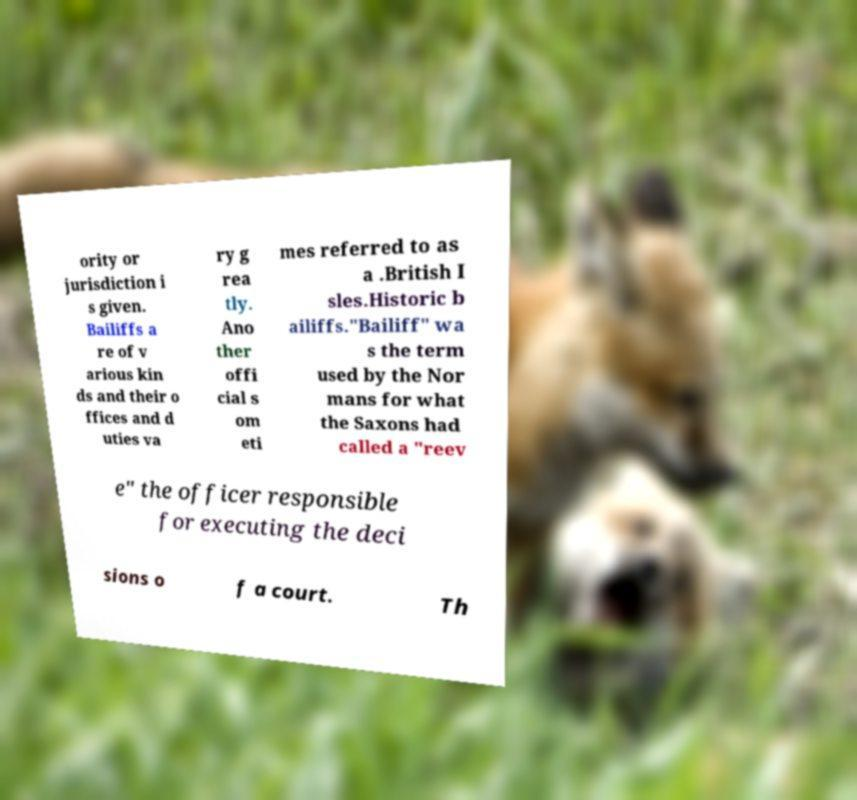Please identify and transcribe the text found in this image. ority or jurisdiction i s given. Bailiffs a re of v arious kin ds and their o ffices and d uties va ry g rea tly. Ano ther offi cial s om eti mes referred to as a .British I sles.Historic b ailiffs."Bailiff" wa s the term used by the Nor mans for what the Saxons had called a "reev e" the officer responsible for executing the deci sions o f a court. Th 